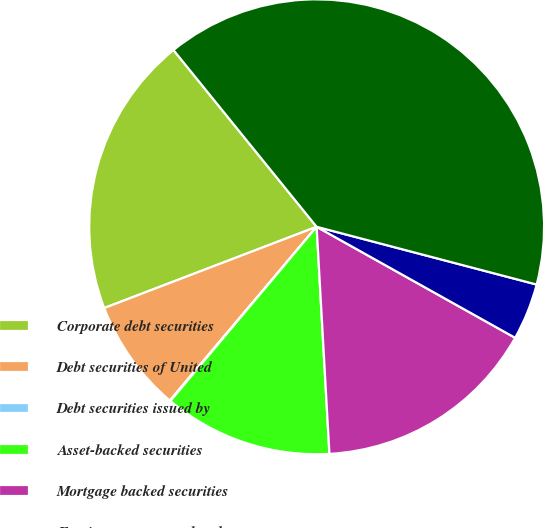<chart> <loc_0><loc_0><loc_500><loc_500><pie_chart><fcel>Corporate debt securities<fcel>Debt securities of United<fcel>Debt securities issued by<fcel>Asset-backed securities<fcel>Mortgage backed securities<fcel>Foreign government bonds<fcel>Total<nl><fcel>19.98%<fcel>8.02%<fcel>0.05%<fcel>12.01%<fcel>15.99%<fcel>4.03%<fcel>39.92%<nl></chart> 